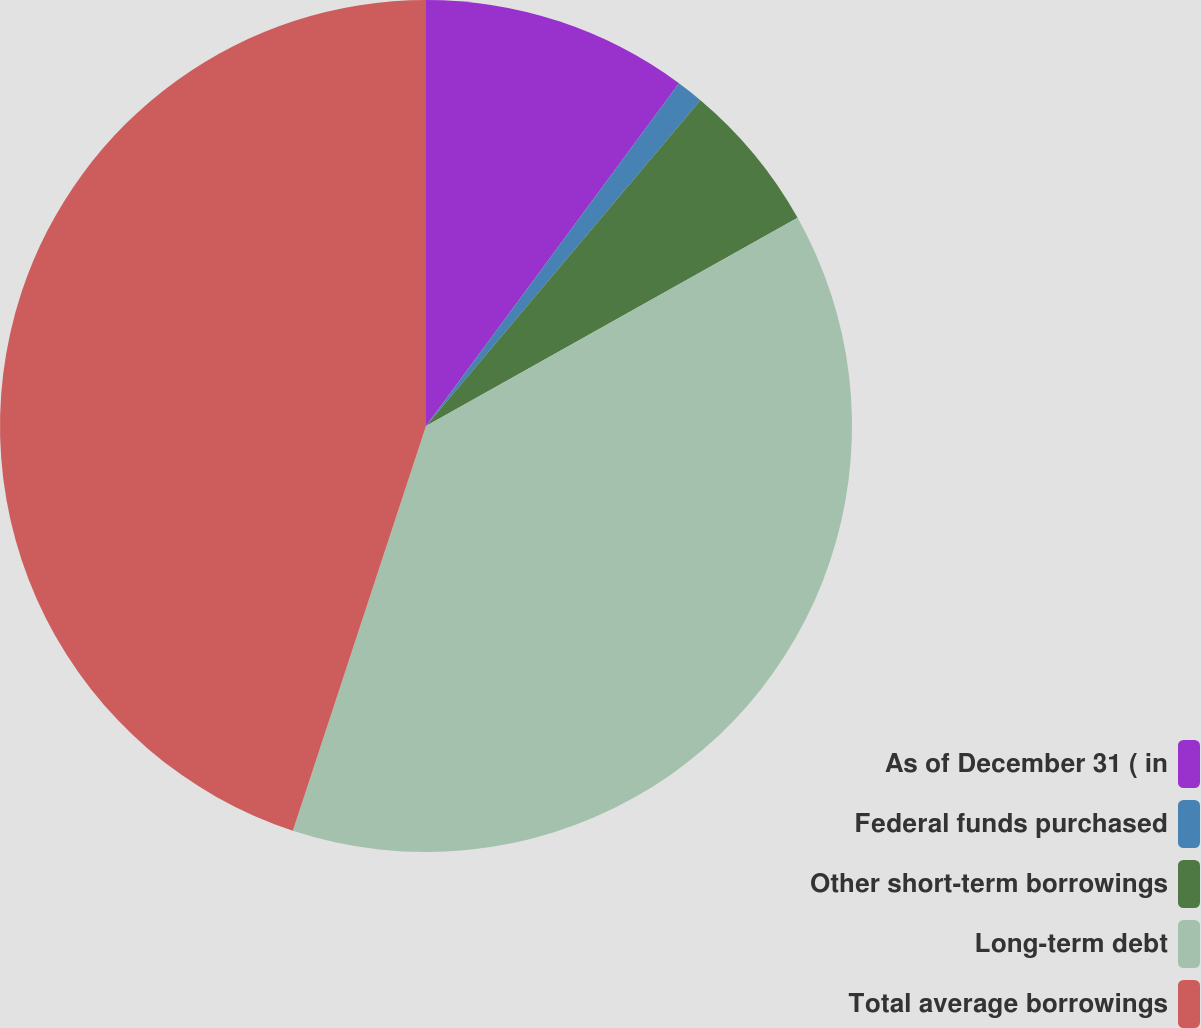Convert chart. <chart><loc_0><loc_0><loc_500><loc_500><pie_chart><fcel>As of December 31 ( in<fcel>Federal funds purchased<fcel>Other short-term borrowings<fcel>Long-term debt<fcel>Total average borrowings<nl><fcel>10.12%<fcel>1.02%<fcel>5.73%<fcel>38.19%<fcel>44.94%<nl></chart> 